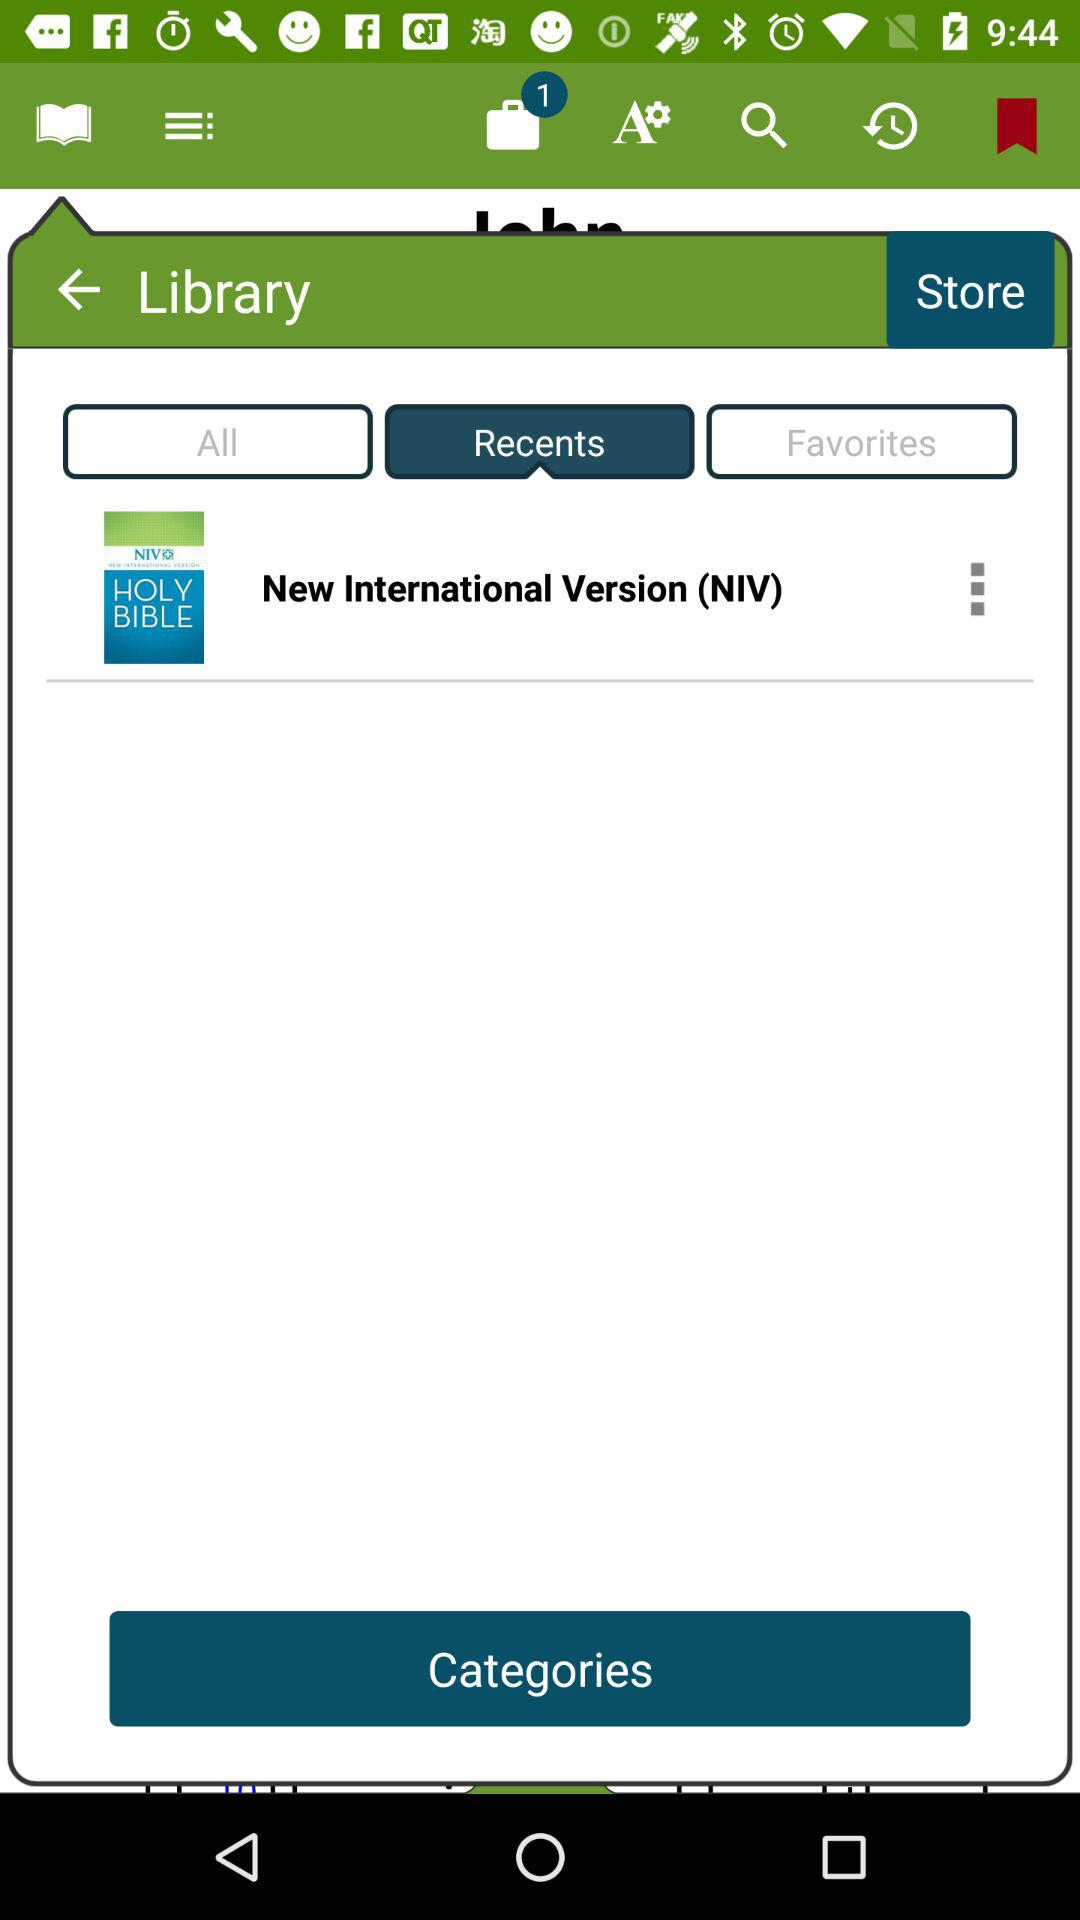Which is the selected tab? The selected tab is "Recents". 